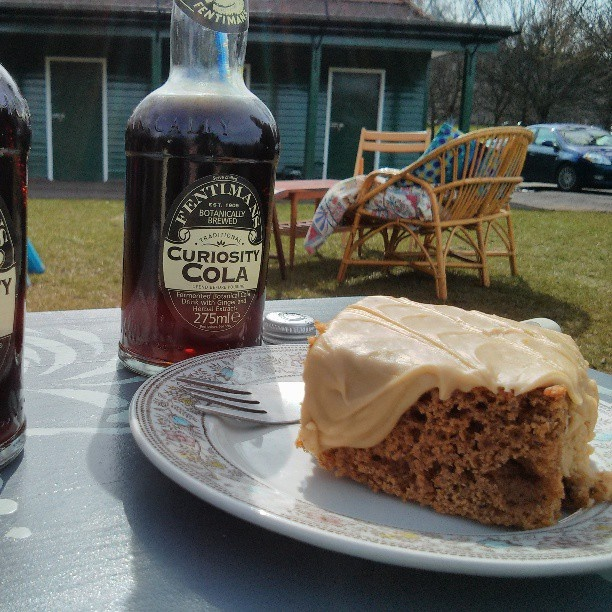Describe the objects in this image and their specific colors. I can see dining table in gray, darkgray, black, and lightgray tones, cake in gray, maroon, black, and tan tones, bottle in gray, black, darkgray, and maroon tones, chair in gray, olive, black, and maroon tones, and bottle in gray, black, darkgray, and maroon tones in this image. 